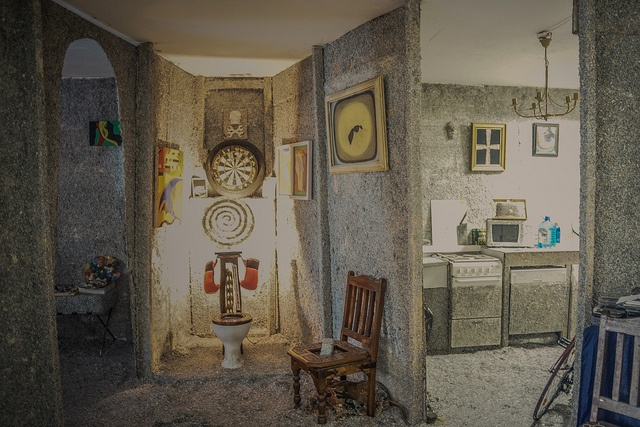Describe the objects in this image and their specific colors. I can see chair in black, maroon, and gray tones, oven in black, gray, and darkgray tones, chair in black, gray, and navy tones, toilet in black and gray tones, and microwave in black, darkgray, and gray tones in this image. 